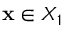Convert formula to latex. <formula><loc_0><loc_0><loc_500><loc_500>x \in X _ { 1 }</formula> 